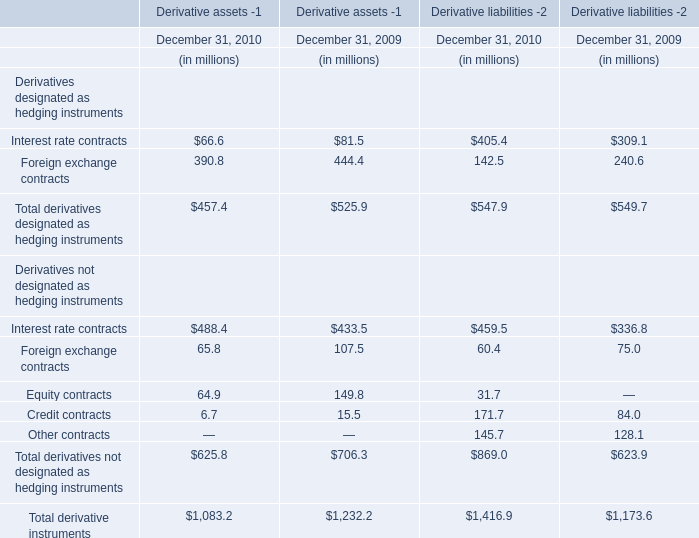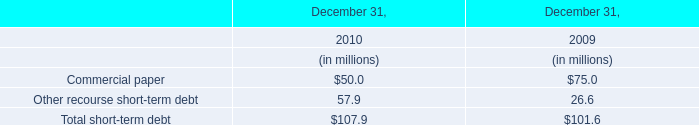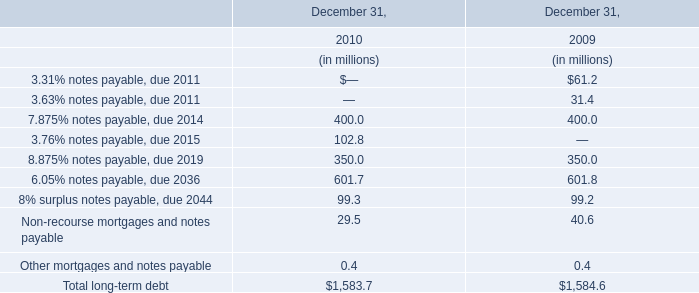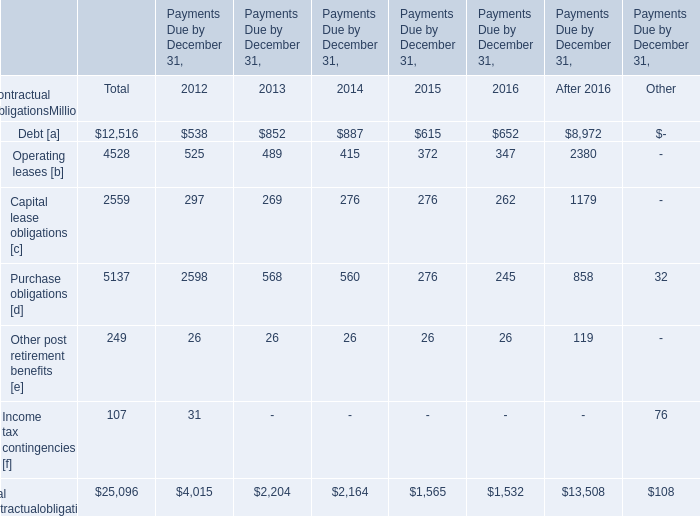What was the total amount of Derivative assets -1 greater than 400 in 2010? (in million) 
Computations: (488.4 + 625.8)
Answer: 1114.2. 